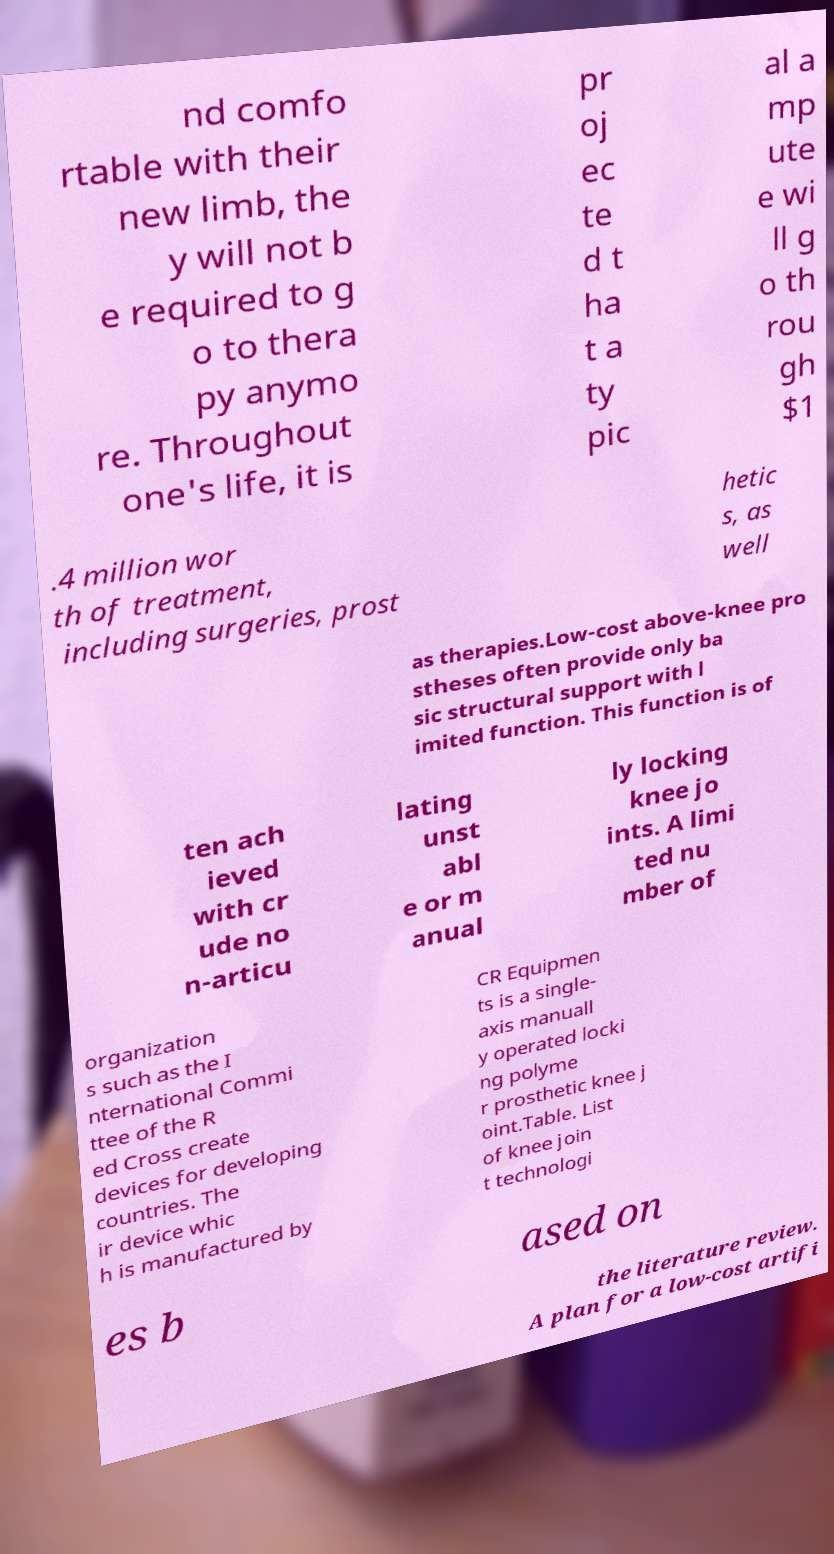Please identify and transcribe the text found in this image. nd comfo rtable with their new limb, the y will not b e required to g o to thera py anymo re. Throughout one's life, it is pr oj ec te d t ha t a ty pic al a mp ute e wi ll g o th rou gh $1 .4 million wor th of treatment, including surgeries, prost hetic s, as well as therapies.Low-cost above-knee pro stheses often provide only ba sic structural support with l imited function. This function is of ten ach ieved with cr ude no n-articu lating unst abl e or m anual ly locking knee jo ints. A limi ted nu mber of organization s such as the I nternational Commi ttee of the R ed Cross create devices for developing countries. The ir device whic h is manufactured by CR Equipmen ts is a single- axis manuall y operated locki ng polyme r prosthetic knee j oint.Table. List of knee join t technologi es b ased on the literature review. A plan for a low-cost artifi 